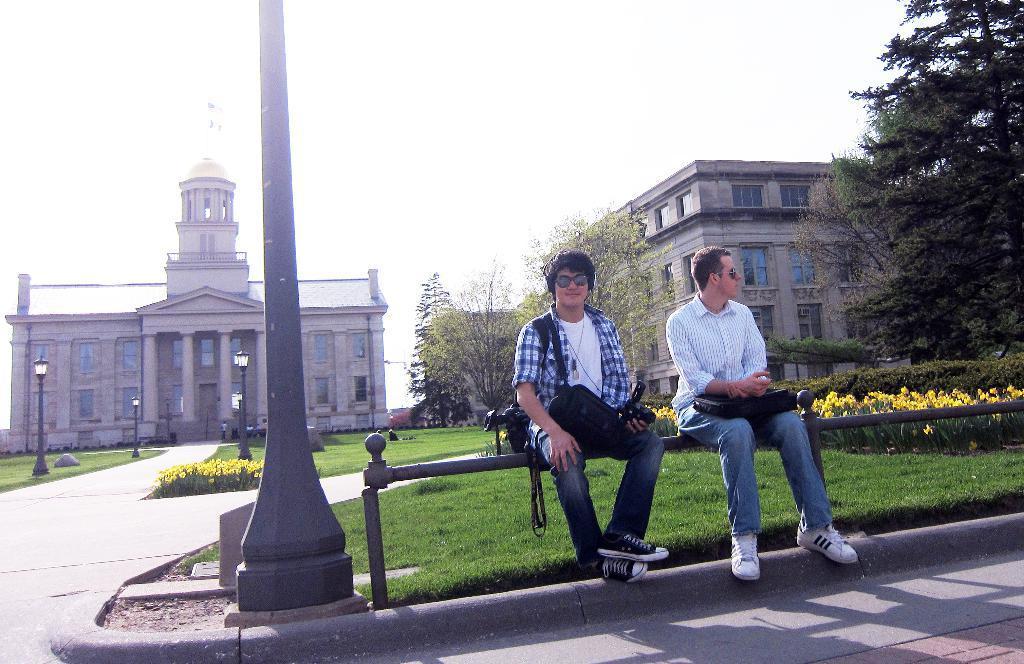Please provide a concise description of this image. In the front of the image I can see railing, pole, grass and people. People are sitting on railing and near them there are objects. In the background of the image there are buildings, trees, plants, light poles, grass, people, sky and objects. 